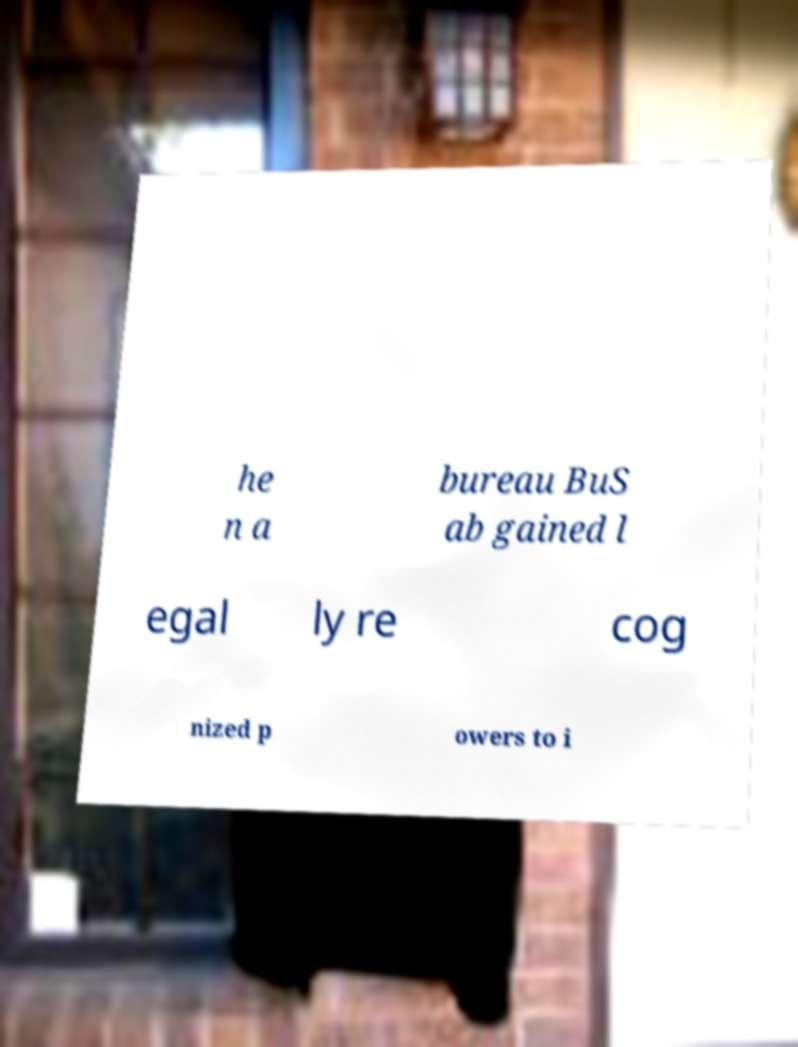Could you assist in decoding the text presented in this image and type it out clearly? he n a bureau BuS ab gained l egal ly re cog nized p owers to i 